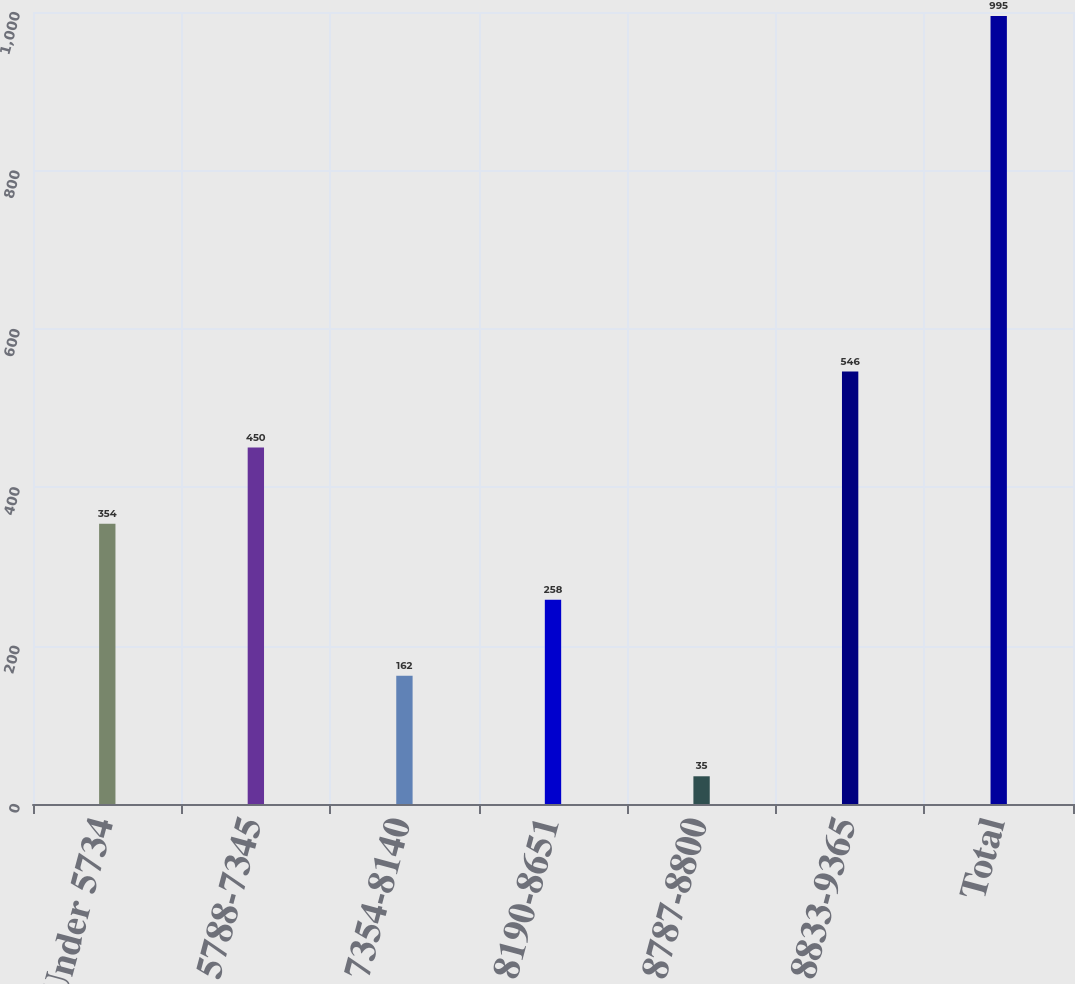<chart> <loc_0><loc_0><loc_500><loc_500><bar_chart><fcel>Under 5734<fcel>5788-7345<fcel>7354-8140<fcel>8190-8651<fcel>8787-8800<fcel>8833-9365<fcel>Total<nl><fcel>354<fcel>450<fcel>162<fcel>258<fcel>35<fcel>546<fcel>995<nl></chart> 